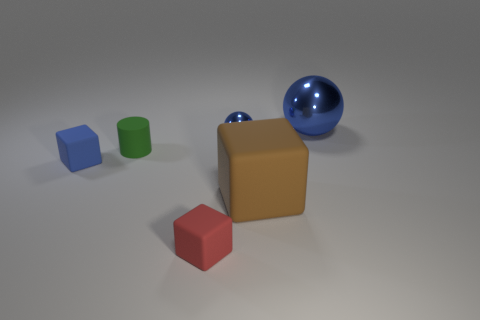How many other things are there of the same material as the green object?
Your response must be concise. 3. There is a small matte block to the left of the green object; does it have the same color as the small metallic sphere?
Your answer should be very brief. Yes. There is a large object behind the big brown thing; are there any metal balls that are behind it?
Offer a very short reply. No. What material is the thing that is both to the left of the large matte object and in front of the blue rubber object?
Keep it short and to the point. Rubber. What shape is the large brown object that is made of the same material as the blue cube?
Give a very brief answer. Cube. Are there any other things that are the same shape as the red rubber thing?
Give a very brief answer. Yes. Do the thing to the right of the brown cube and the large block have the same material?
Your response must be concise. No. There is a cube that is left of the red cube; what is its material?
Your answer should be very brief. Rubber. There is a blue ball behind the blue ball that is in front of the large blue metal thing; what size is it?
Keep it short and to the point. Large. How many metallic spheres have the same size as the cylinder?
Offer a terse response. 1. 